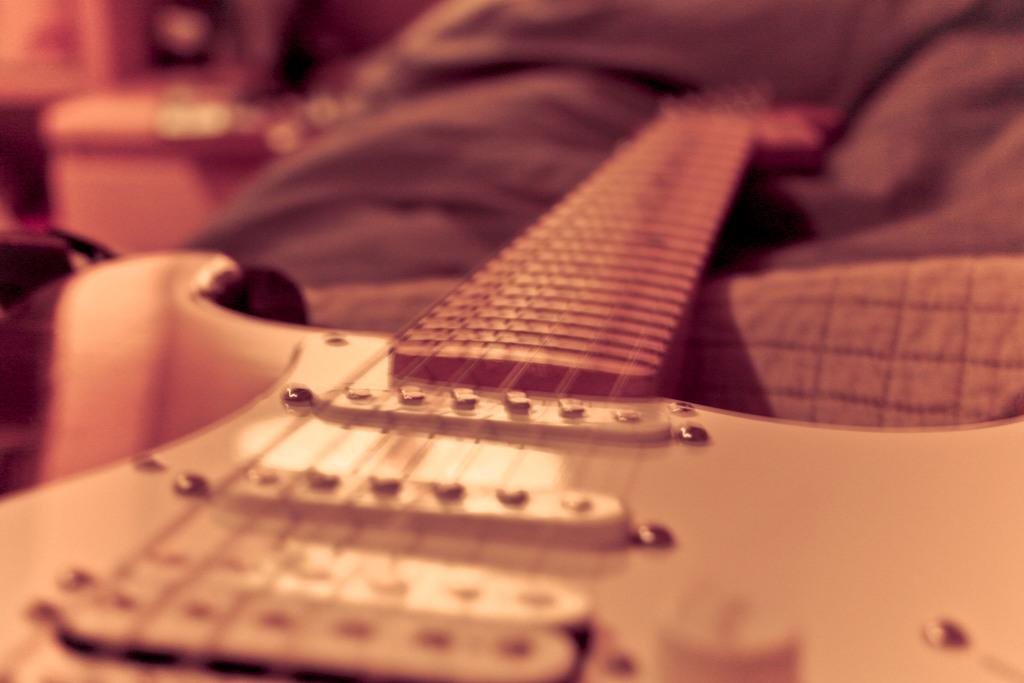What musical instrument is present in the image? There is a guitar in the image. How many cats are sitting on the guitar in the image? There are no cats present in the image; it only features a guitar. Is there any visible steam coming from the guitar in the image? There is no steam visible in the image; it only features a guitar. 